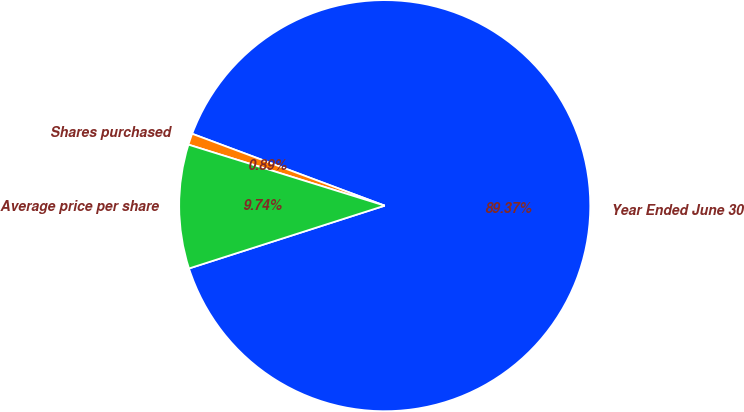Convert chart to OTSL. <chart><loc_0><loc_0><loc_500><loc_500><pie_chart><fcel>Year Ended June 30<fcel>Shares purchased<fcel>Average price per share<nl><fcel>89.37%<fcel>0.89%<fcel>9.74%<nl></chart> 